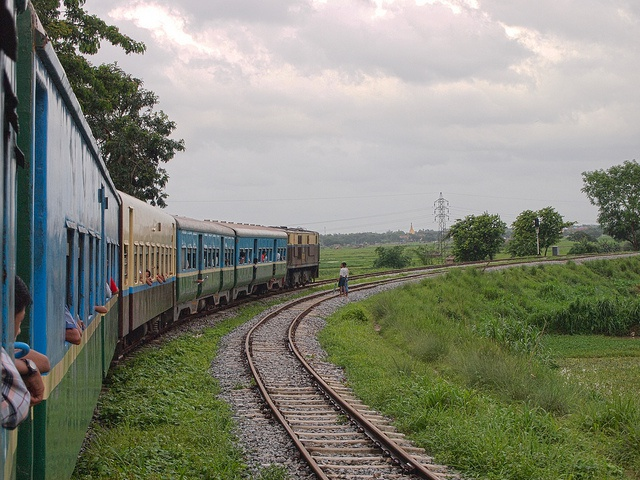Describe the objects in this image and their specific colors. I can see train in black, gray, darkgray, and darkgreen tones, people in black, gray, maroon, and brown tones, people in black, gray, maroon, and brown tones, people in black, gray, darkgray, and maroon tones, and people in black, gray, darkgray, and maroon tones in this image. 